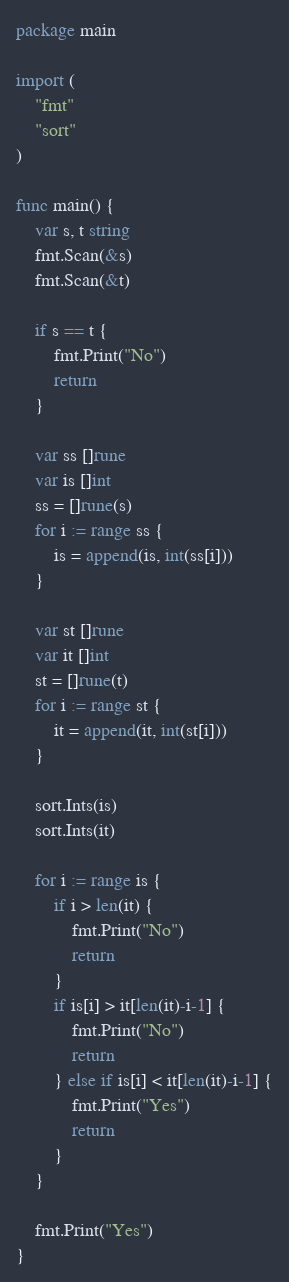<code> <loc_0><loc_0><loc_500><loc_500><_Go_>package main

import (
	"fmt"
	"sort"
)

func main() {
	var s, t string
	fmt.Scan(&s)
	fmt.Scan(&t)

	if s == t {
		fmt.Print("No")
		return
	}

	var ss []rune
	var is []int
	ss = []rune(s)
	for i := range ss {
		is = append(is, int(ss[i]))
	}

	var st []rune
	var it []int
	st = []rune(t)
	for i := range st {
		it = append(it, int(st[i]))
	}

	sort.Ints(is)
	sort.Ints(it)

	for i := range is {
		if i > len(it) {
			fmt.Print("No")
			return
		}
		if is[i] > it[len(it)-i-1] {
			fmt.Print("No")
			return
		} else if is[i] < it[len(it)-i-1] {
			fmt.Print("Yes")
			return
		}
	}

	fmt.Print("Yes")
}
</code> 